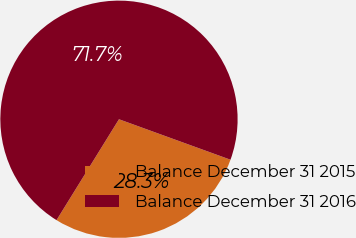Convert chart. <chart><loc_0><loc_0><loc_500><loc_500><pie_chart><fcel>Balance December 31 2015<fcel>Balance December 31 2016<nl><fcel>28.28%<fcel>71.72%<nl></chart> 